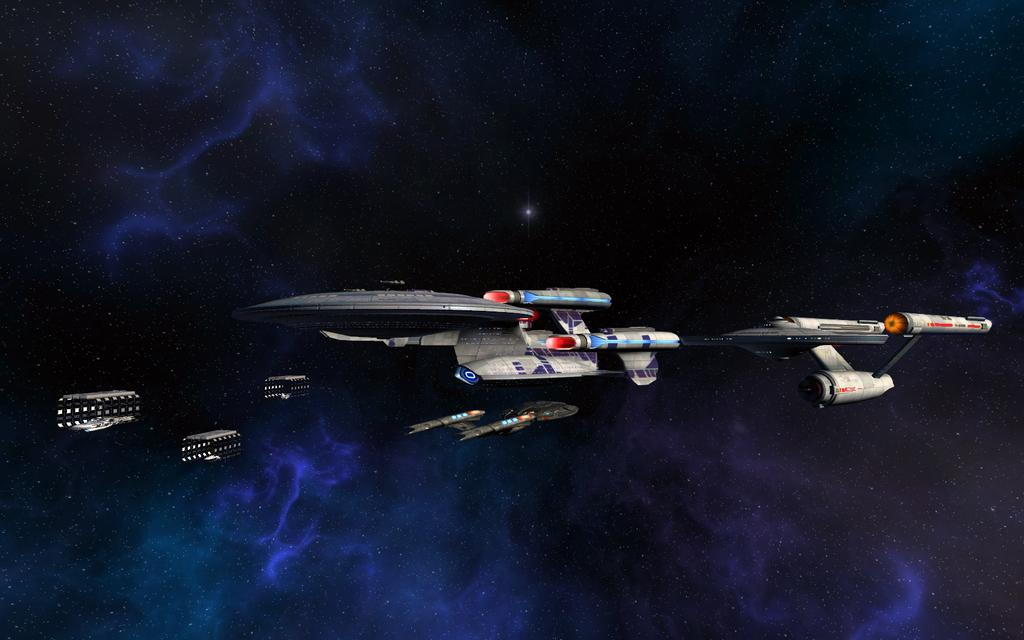What is depicted in the sky in the image? There are spaceships in the sky in the image. How many eggs are being stirred with a spoon in the image? There are no eggs or spoons present in the image; it features spaceships in the sky. 